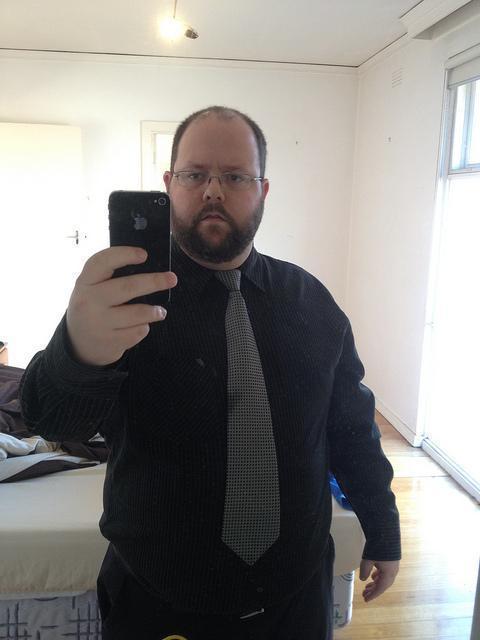What is the man taking?
Choose the right answer and clarify with the format: 'Answer: answer
Rationale: rationale.'
Options: Selfie, karate class, online course, bar exam. Answer: selfie.
Rationale: The man takes a selfie. 